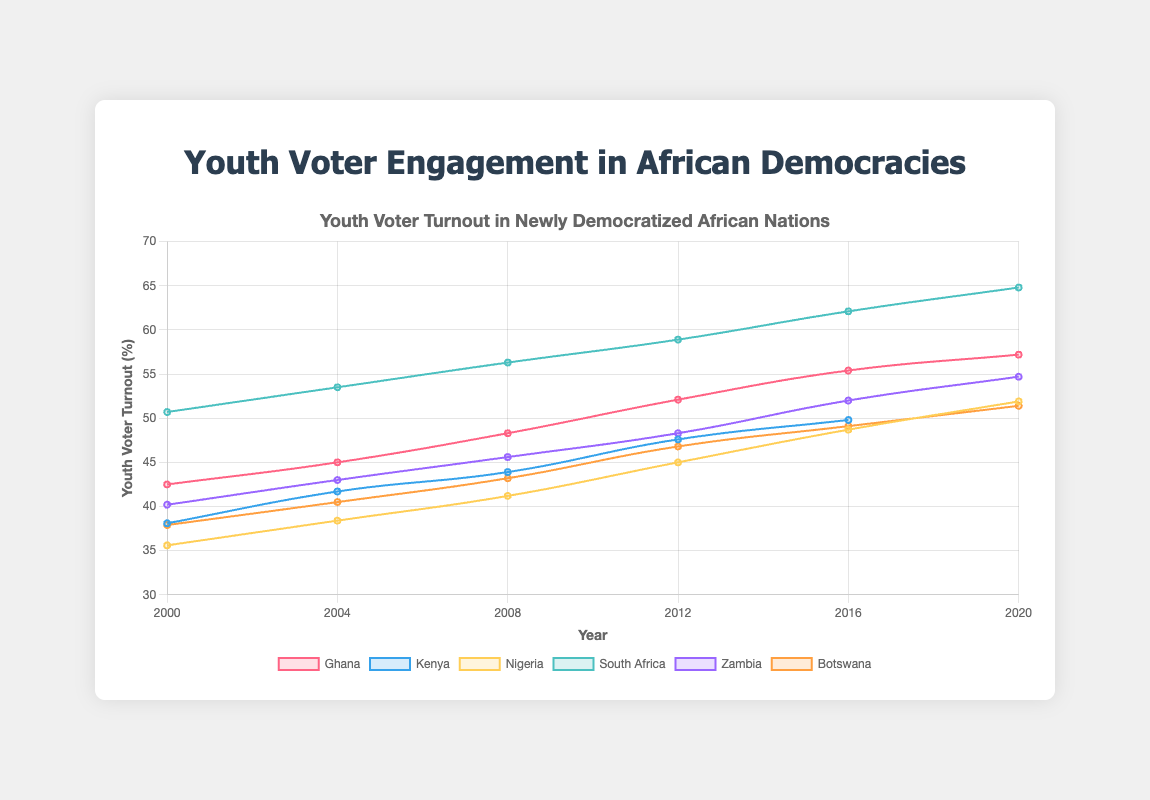What's the largest increase in youth voter turnout within a single election period for South Africa? To determine the largest increase within a single election period for South Africa, we compare the differences between consecutive years: 1999-1994 (53.5-50.7=2.8), 2004-1999 (56.3-53.5=2.8), 2009-2004 (58.9-56.3=2.6), 2014-2009 (62.1-58.9=3.2), 2019-2014 (64.8-62.1=2.7). The largest increase is 3.2 between 2009 and 2014.
Answer: 3.2 Which country had the highest youth voter turnout in the latest election year recorded? Compare the turnout rates for the last year for each country: Ghana (57.2 in 2020), Kenya (49.8 in 2022), Nigeria (51.9 in 2019), South Africa (64.8 in 2019), Zambia (54.7 in 2016), and Botswana (51.4 in 2019). South Africa has the highest turnout in 2019.
Answer: South Africa Between Ghana and Kenya, which country had a higher youth voter turnout in 2008? Look at the youth voter turnout for Ghana in 2008 (48.3) and for Kenya in 2008 (data not available, only 2007 and 2013); since Kenya's data is unavailable, Ghana had a higher turnout.
Answer: Ghana How did Nigeria's youth voter turnout change between 1999 and 2015? To determine the change, calculate the difference in turnout between 2015 (48.7%) and 1999 (35.6%): 48.7 - 35.6 = 13.1.
Answer: 13.1 Which country shows a steady increase in youth voter turnout across all recorded election years? Assess each country's data: Ghana (42.5 to 57.2), Kenya (38.1 to 49.8), Nigeria (35.6 to 51.9), South Africa (50.7 to 64.8), Zambia (40.2 to 54.7), Botswana (37.9 to 51.4). All countries show a steady increase without any decrease across the years.
Answer: Multiple countries (Ghana, Kenya, Nigeria, South Africa, Zambia, Botswana) What is the average youth voter turnout for Botswana across all recorded years? Sum the turnout percentages: 37.9 + 40.5 + 43.2 + 46.8 + 49.1 + 51.4 = 268.9, then divide by the number of years: 268.9 / 6 = 44.82.
Answer: 44.82 Which country had the lowest youth voter turnout in 1999? Compare the 1999 turnout for available countries: South Africa (53.5), Nigeria (35.6), Zambia (43.0), Botswana (40.5). Nigeria had the lowest at 35.6%
Answer: Nigeria 